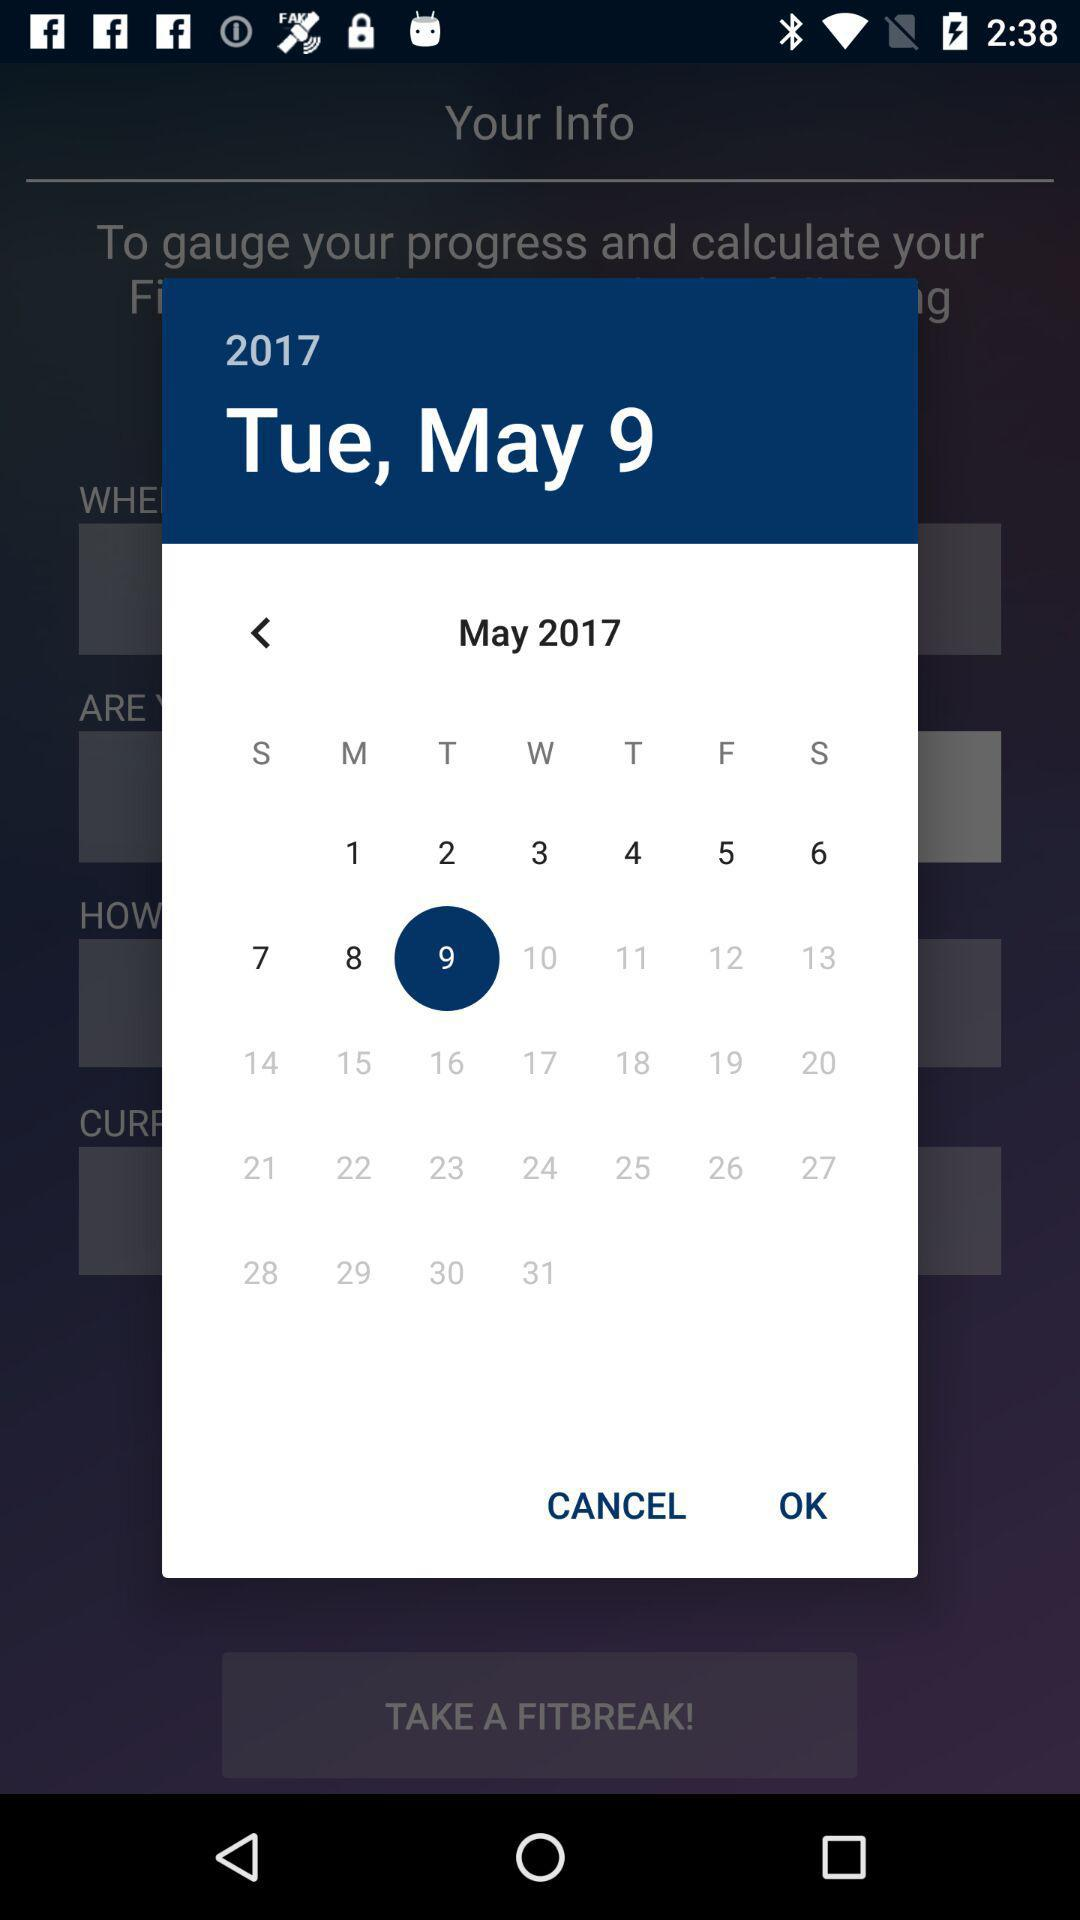What is the day on May 9? The day is Tuesday. 